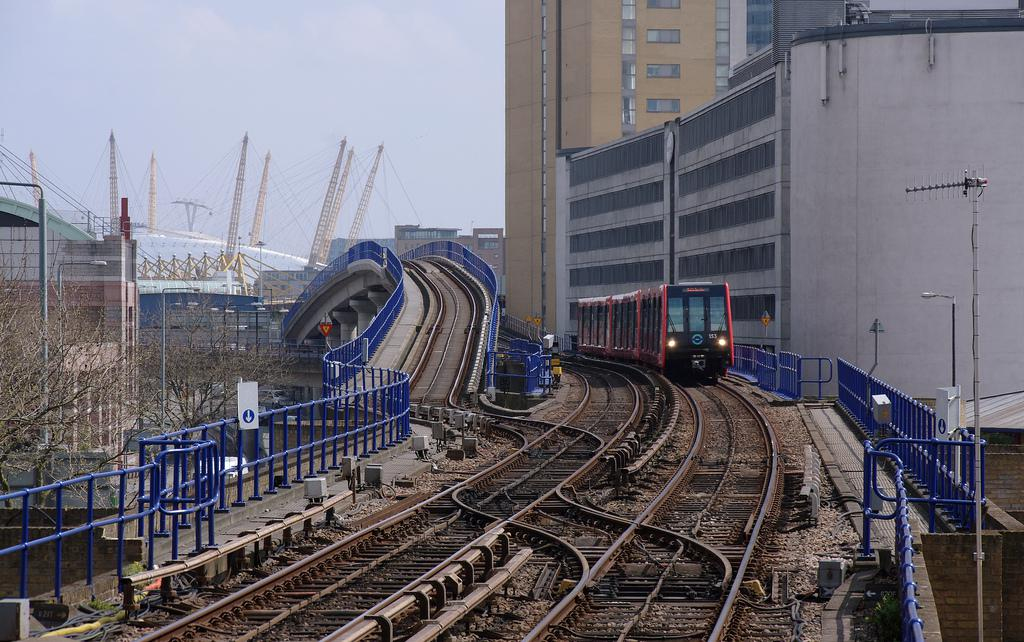Question: how was the weather?
Choices:
A. Clear.
B. Foggy.
C. Wet.
D. Sunny.
Answer with the letter. Answer: A Question: why was the train moving?
Choices:
A. To carry passengers.
B. To carry equipment.
C. To travel.
D. TO dilever items.
Answer with the letter. Answer: A Question: what color is the train?
Choices:
A. Black.
B. Grey.
C. Blue.
D. Red.
Answer with the letter. Answer: D Question: what time of day does it look like?
Choices:
A. Night.
B. Afternoon.
C. Morning.
D. Noon.
Answer with the letter. Answer: C Question: where was this picture taken?
Choices:
A. At the bank.
B. At six flags.
C. On the tracks.
D. At the restaurant.
Answer with the letter. Answer: C Question: where do the train tracks on the left go?
Choices:
A. Up over the city.
B. To the town.
C. Another country.
D. Next station.
Answer with the letter. Answer: A Question: what are the brightest objects on the train?
Choices:
A. Chairs.
B. The headlights.
C. Floor.
D. Ceiling.
Answer with the letter. Answer: B Question: what tall objects can be seen in the distance?
Choices:
A. Building.
B. Tower.
C. Construction cranes.
D. Satellites.
Answer with the letter. Answer: C Question: what vehicle is approaching?
Choices:
A. Bus.
B. Car.
C. A train.
D. Truck.
Answer with the letter. Answer: C Question: where are tall buildings positioned?
Choices:
A. Behind the fence.
B. In the back ground.
C. Right next to the tracks.
D. Behind the train.
Answer with the letter. Answer: C Question: what does the photograph show?
Choices:
A. The family.
B. A street.
C. A complicated network of train tracks.
D. A park.
Answer with the letter. Answer: C Question: what are without leaves?
Choices:
A. Plants.
B. Trees.
C. Fruit.
D. Grass.
Answer with the letter. Answer: B Question: what color is the building on the right?
Choices:
A. Gray.
B. Black.
C. Brown.
D. Mirror.
Answer with the letter. Answer: A Question: how many lights are on on the train?
Choices:
A. 2.
B. 9.
C. 4.
D. 6.
Answer with the letter. Answer: A Question: what are curved?
Choices:
A. Streets.
B. Race tracks.
C. Cups.
D. Sections of tracks.
Answer with the letter. Answer: D Question: what is red train running through?
Choices:
A. Urban area.
B. Rural area.
C. Park.
D. Woods.
Answer with the letter. Answer: A Question: what is visible on tracks?
Choices:
A. Red train.
B. Blue train.
C. Yellow train.
D. White train.
Answer with the letter. Answer: A Question: where is the blue fence?
Choices:
A. Next to the train tracks.
B. Around the flower garden.
C. Downtown in the park.
D. Around the race track.
Answer with the letter. Answer: A Question: what color are the railings?
Choices:
A. Black.
B. White.
C. Red.
D. Blue.
Answer with the letter. Answer: D 